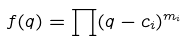Convert formula to latex. <formula><loc_0><loc_0><loc_500><loc_500>f ( q ) = \prod ( q - c _ { i } ) ^ { m _ { i } }</formula> 